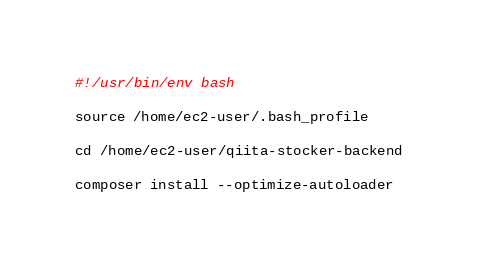Convert code to text. <code><loc_0><loc_0><loc_500><loc_500><_Bash_>#!/usr/bin/env bash

source /home/ec2-user/.bash_profile

cd /home/ec2-user/qiita-stocker-backend

composer install --optimize-autoloader
</code> 